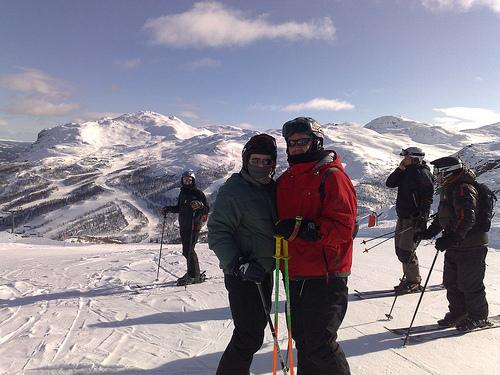List the colors of ski poles present in the image. Orange, green, and black. What is the weather like in the image? Bright with blue sky and light, fluffy clouds. Describe the landscape in the image. Snowy mountainous with snow-covered slopes and ski tracks in the snow. What color are the ski coats worn by the two main characters in the image? One skier is in a red ski coat, and the other is in a green ski coat. What special accessory does the skier on the right have? A black backpack on his back. Discuss the visual entailment of the scene. The scene entails a group of people skiing on snow-covered slopes with a mountainous landscape in the background, suggesting an active and enjoyable winter sport experience. What type of product could be advertised using this image? Winter sports gear, ski equipment, or ski resort vacations. What type of headwear do the skiers have? Helmets and goggles. How many skiers can be seen at the top of the ski slope? Three skiers. 